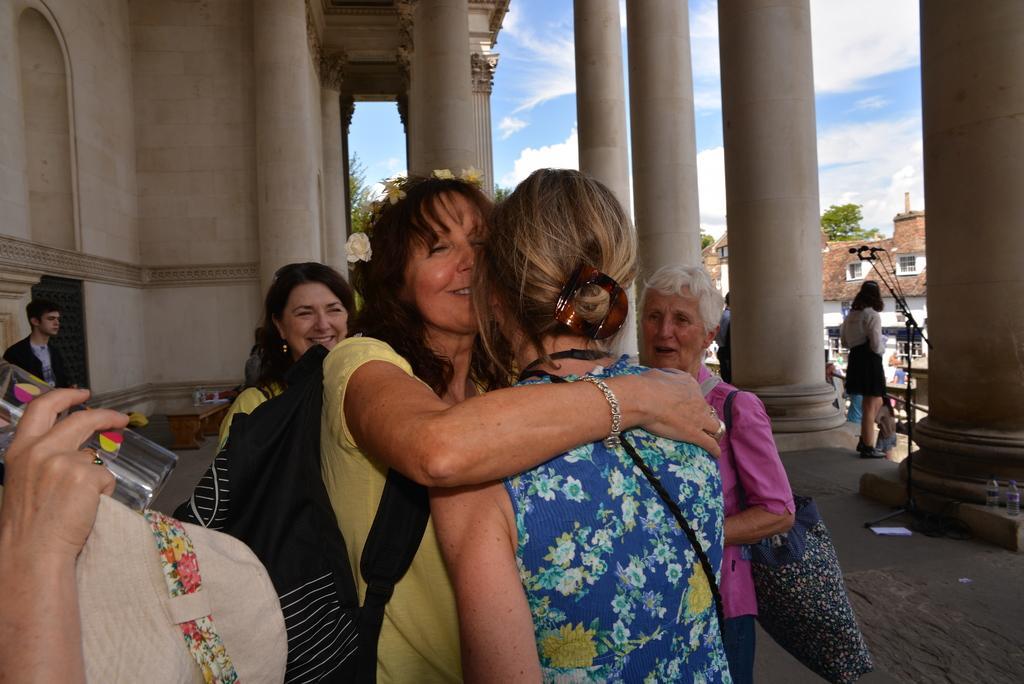In one or two sentences, can you explain what this image depicts? In this image there are a few people standing. In the center there are two women hugging each other. Beside them there are pillars. To the left there is a wall of a building. Near to the pillar there is a microphone. In the background there are buildings and trees. At the top there is the sky. 